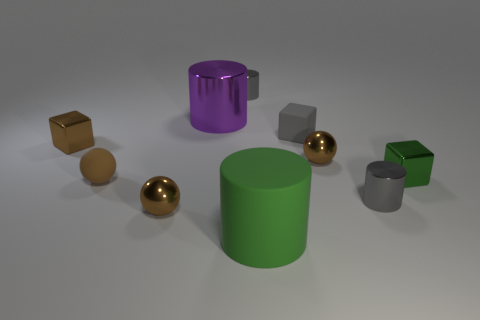What material is the cube that is the same color as the matte ball?
Ensure brevity in your answer.  Metal. Do the purple cylinder and the matte cube have the same size?
Offer a very short reply. No. What number of things are either blue matte objects or metal things behind the tiny green object?
Provide a short and direct response. 4. There is another cylinder that is the same size as the rubber cylinder; what material is it?
Offer a very short reply. Metal. The cylinder that is both in front of the tiny green object and left of the rubber cube is made of what material?
Provide a succinct answer. Rubber. Is there a tiny brown sphere in front of the rubber thing left of the green cylinder?
Give a very brief answer. Yes. How big is the gray object that is behind the brown matte object and on the right side of the green cylinder?
Your answer should be compact. Small. How many gray objects are rubber cylinders or small rubber cylinders?
Make the answer very short. 0. The green object that is the same size as the purple metal object is what shape?
Your answer should be compact. Cylinder. What number of other things are there of the same color as the rubber cylinder?
Keep it short and to the point. 1. 